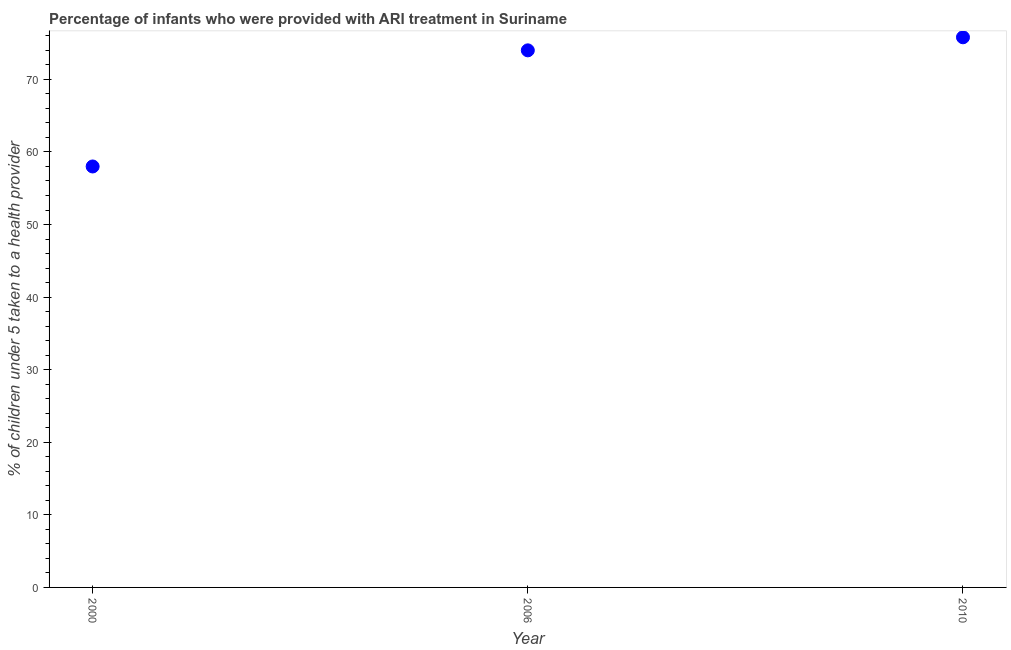What is the percentage of children who were provided with ari treatment in 2000?
Provide a succinct answer. 58. Across all years, what is the maximum percentage of children who were provided with ari treatment?
Keep it short and to the point. 75.8. Across all years, what is the minimum percentage of children who were provided with ari treatment?
Provide a succinct answer. 58. In which year was the percentage of children who were provided with ari treatment minimum?
Your answer should be compact. 2000. What is the sum of the percentage of children who were provided with ari treatment?
Your answer should be very brief. 207.8. What is the difference between the percentage of children who were provided with ari treatment in 2006 and 2010?
Keep it short and to the point. -1.8. What is the average percentage of children who were provided with ari treatment per year?
Offer a very short reply. 69.27. What is the ratio of the percentage of children who were provided with ari treatment in 2006 to that in 2010?
Provide a short and direct response. 0.98. Is the percentage of children who were provided with ari treatment in 2006 less than that in 2010?
Your response must be concise. Yes. Is the difference between the percentage of children who were provided with ari treatment in 2000 and 2006 greater than the difference between any two years?
Your answer should be compact. No. What is the difference between the highest and the second highest percentage of children who were provided with ari treatment?
Ensure brevity in your answer.  1.8. What is the difference between the highest and the lowest percentage of children who were provided with ari treatment?
Your answer should be compact. 17.8. Does the percentage of children who were provided with ari treatment monotonically increase over the years?
Make the answer very short. Yes. How many years are there in the graph?
Provide a short and direct response. 3. What is the difference between two consecutive major ticks on the Y-axis?
Ensure brevity in your answer.  10. What is the title of the graph?
Make the answer very short. Percentage of infants who were provided with ARI treatment in Suriname. What is the label or title of the X-axis?
Keep it short and to the point. Year. What is the label or title of the Y-axis?
Your answer should be very brief. % of children under 5 taken to a health provider. What is the % of children under 5 taken to a health provider in 2000?
Your answer should be very brief. 58. What is the % of children under 5 taken to a health provider in 2006?
Provide a succinct answer. 74. What is the % of children under 5 taken to a health provider in 2010?
Offer a very short reply. 75.8. What is the difference between the % of children under 5 taken to a health provider in 2000 and 2010?
Your answer should be very brief. -17.8. What is the ratio of the % of children under 5 taken to a health provider in 2000 to that in 2006?
Your response must be concise. 0.78. What is the ratio of the % of children under 5 taken to a health provider in 2000 to that in 2010?
Provide a succinct answer. 0.77. 